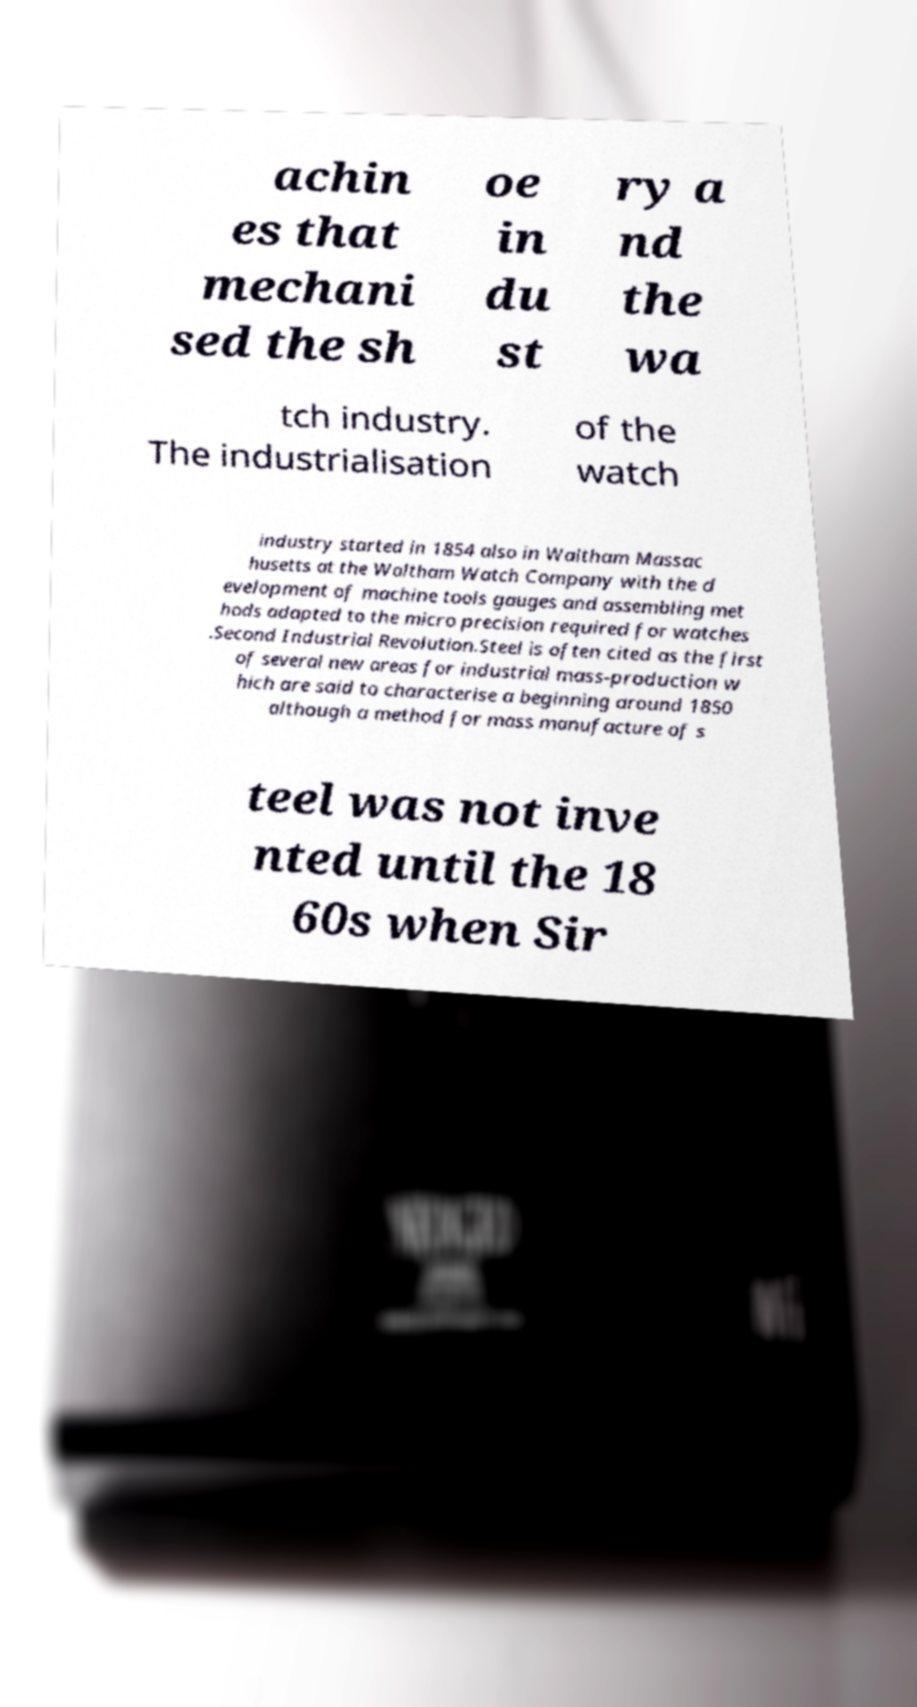Can you read and provide the text displayed in the image?This photo seems to have some interesting text. Can you extract and type it out for me? achin es that mechani sed the sh oe in du st ry a nd the wa tch industry. The industrialisation of the watch industry started in 1854 also in Waltham Massac husetts at the Waltham Watch Company with the d evelopment of machine tools gauges and assembling met hods adapted to the micro precision required for watches .Second Industrial Revolution.Steel is often cited as the first of several new areas for industrial mass-production w hich are said to characterise a beginning around 1850 although a method for mass manufacture of s teel was not inve nted until the 18 60s when Sir 